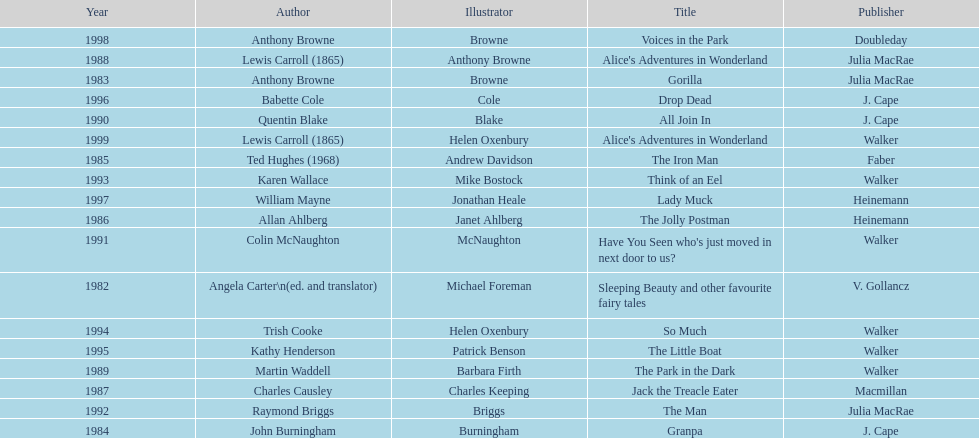Which other author, besides lewis carroll, has won the kurt maschler award twice? Anthony Browne. 